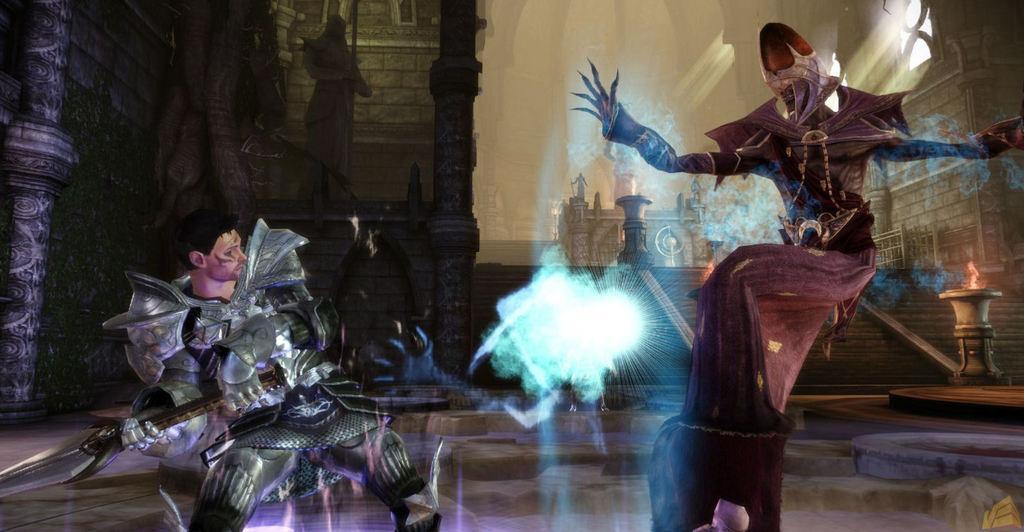Can you describe this image briefly? In this image we can see an animated picture, there are two persons in that, on of them are holding a sword, there is a sculpture, pillar, walls, and a staircase, we can also we a building. 